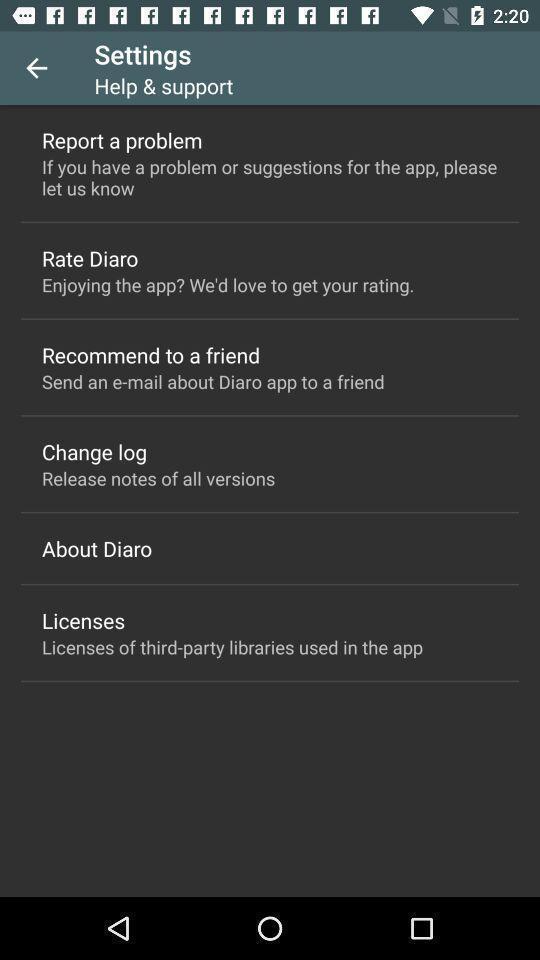Tell me what you see in this picture. Settings page with multiple options. 